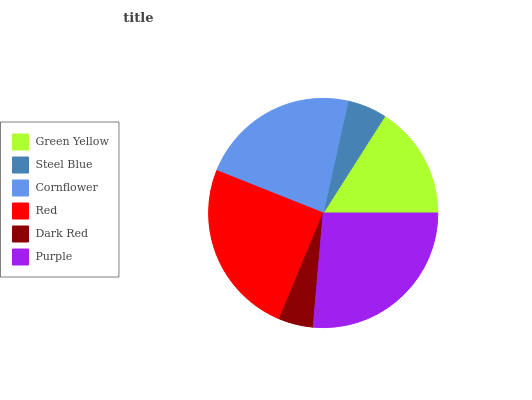Is Dark Red the minimum?
Answer yes or no. Yes. Is Purple the maximum?
Answer yes or no. Yes. Is Steel Blue the minimum?
Answer yes or no. No. Is Steel Blue the maximum?
Answer yes or no. No. Is Green Yellow greater than Steel Blue?
Answer yes or no. Yes. Is Steel Blue less than Green Yellow?
Answer yes or no. Yes. Is Steel Blue greater than Green Yellow?
Answer yes or no. No. Is Green Yellow less than Steel Blue?
Answer yes or no. No. Is Cornflower the high median?
Answer yes or no. Yes. Is Green Yellow the low median?
Answer yes or no. Yes. Is Steel Blue the high median?
Answer yes or no. No. Is Dark Red the low median?
Answer yes or no. No. 